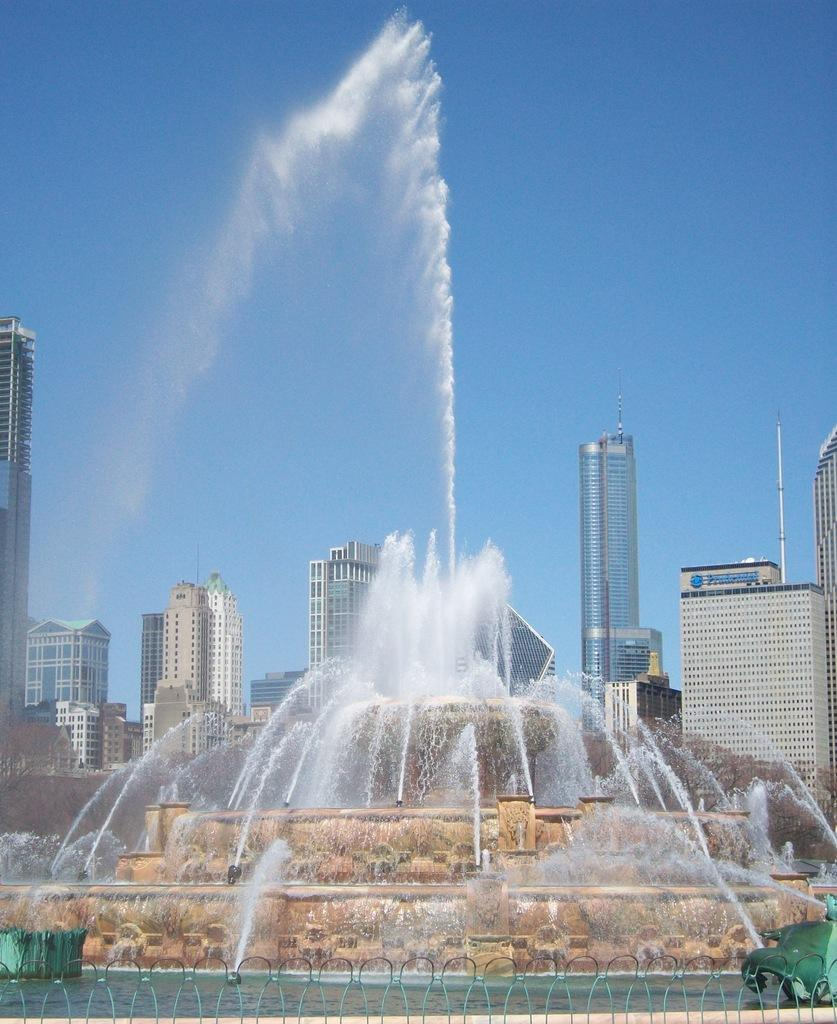What type of barrier can be seen in the image? There is a fence in the image. What is located near the fence? There is water near the fence. What natural feature is present near the water? There are waterfalls near the water. What can be seen in the distance in the image? There are buildings in the background of the image. What is the color of the sky in the background of the image? The sky is blue in the background of the image. What flavor of ice cream is being sold by the organization near the fence? There is no ice cream or organization present in the image. 